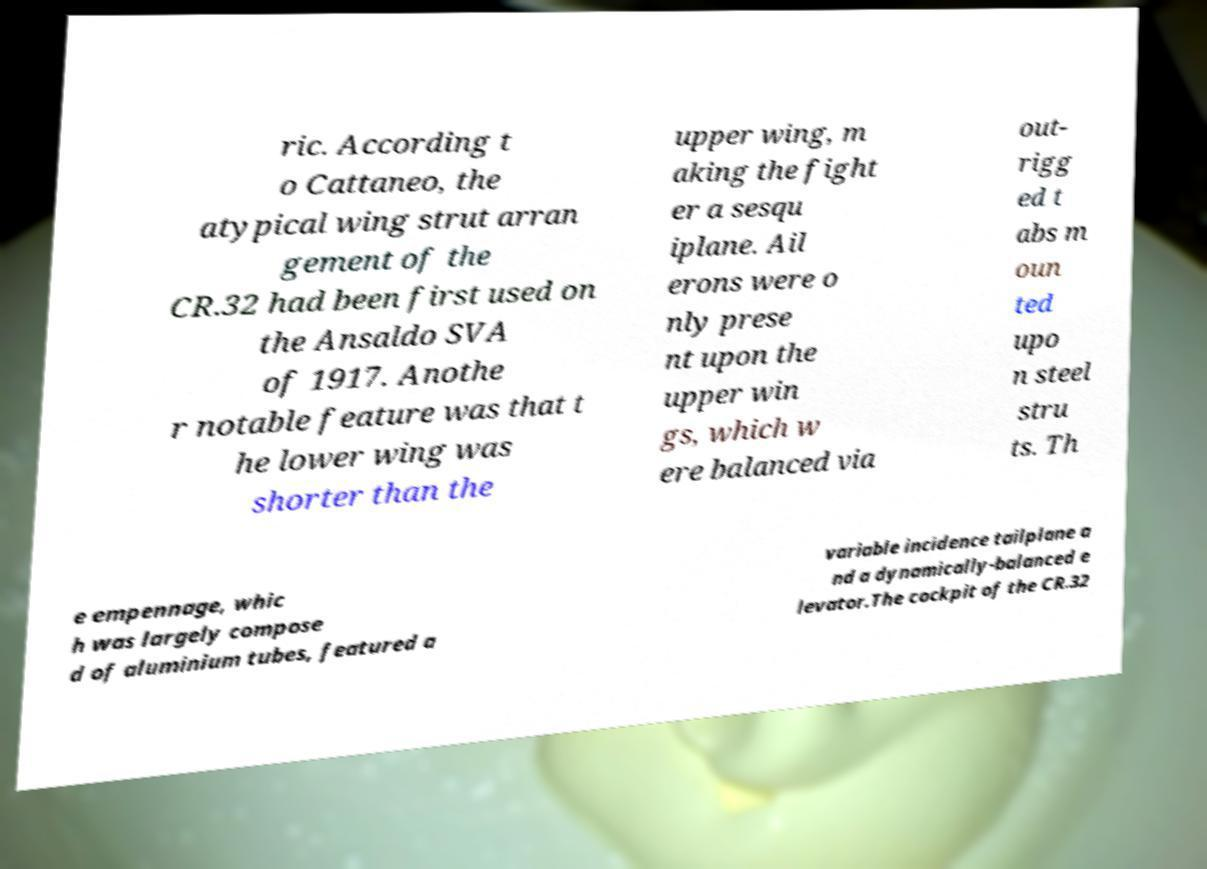Please identify and transcribe the text found in this image. ric. According t o Cattaneo, the atypical wing strut arran gement of the CR.32 had been first used on the Ansaldo SVA of 1917. Anothe r notable feature was that t he lower wing was shorter than the upper wing, m aking the fight er a sesqu iplane. Ail erons were o nly prese nt upon the upper win gs, which w ere balanced via out- rigg ed t abs m oun ted upo n steel stru ts. Th e empennage, whic h was largely compose d of aluminium tubes, featured a variable incidence tailplane a nd a dynamically-balanced e levator.The cockpit of the CR.32 